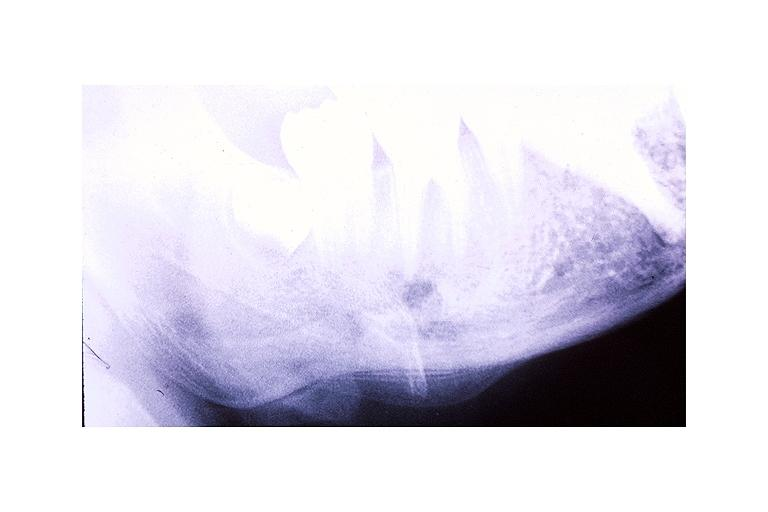s oral present?
Answer the question using a single word or phrase. Yes 